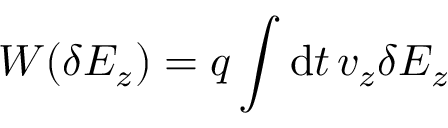<formula> <loc_0><loc_0><loc_500><loc_500>W ( \delta E _ { z } ) = q \int d t \, v _ { z } \delta E _ { z }</formula> 